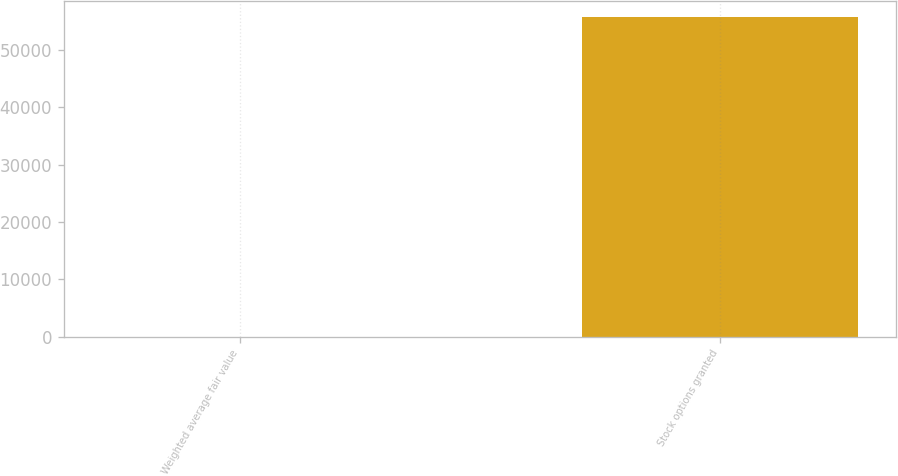<chart> <loc_0><loc_0><loc_500><loc_500><bar_chart><fcel>Weighted average fair value<fcel>Stock options granted<nl><fcel>0.93<fcel>55668<nl></chart> 